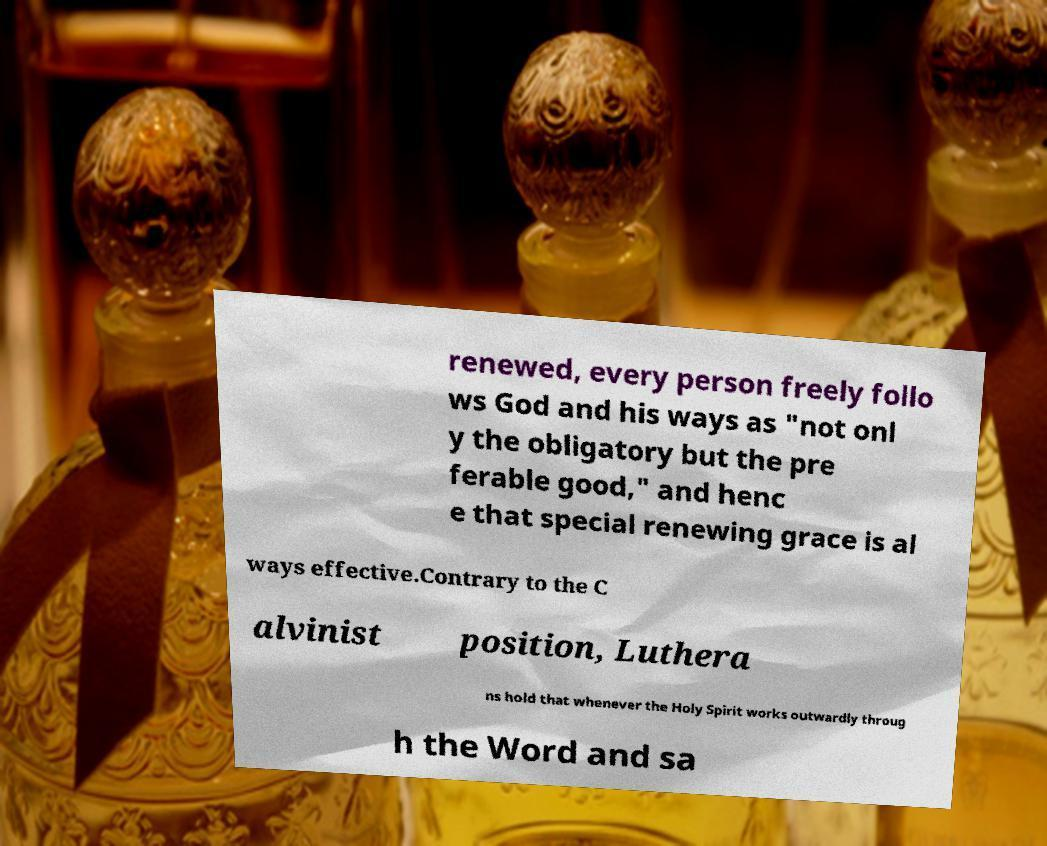I need the written content from this picture converted into text. Can you do that? renewed, every person freely follo ws God and his ways as "not onl y the obligatory but the pre ferable good," and henc e that special renewing grace is al ways effective.Contrary to the C alvinist position, Luthera ns hold that whenever the Holy Spirit works outwardly throug h the Word and sa 